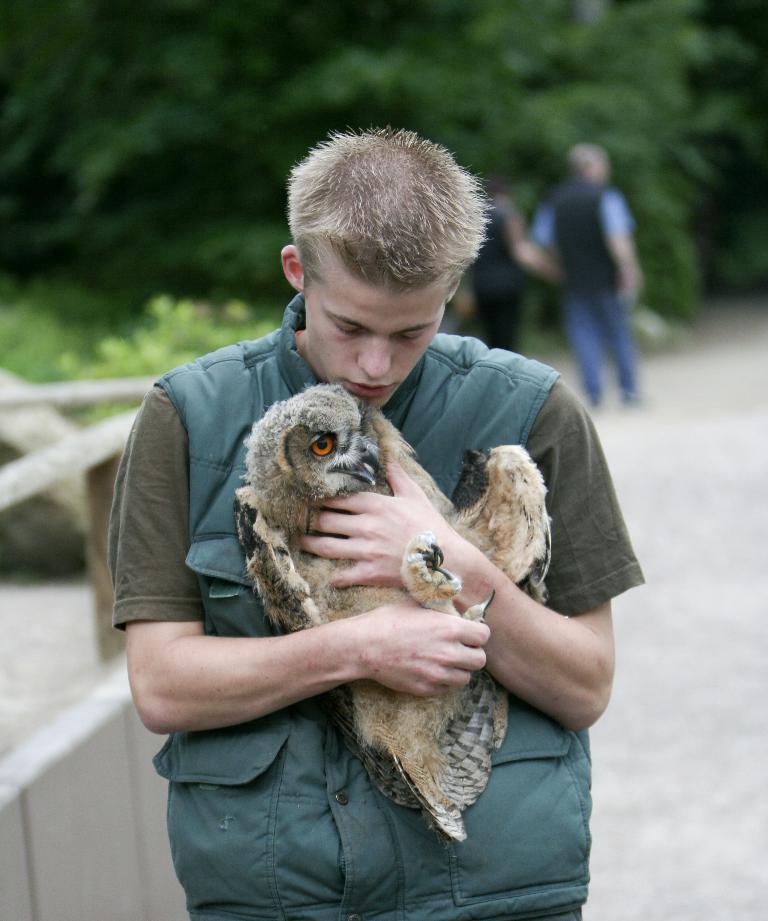Describe this image in one or two sentences. In this picture, we can see a few people, and among them we can see a person holding a bird, and we can see some objects in the bottom left side of the picture, ground, and blurred background with plants. 